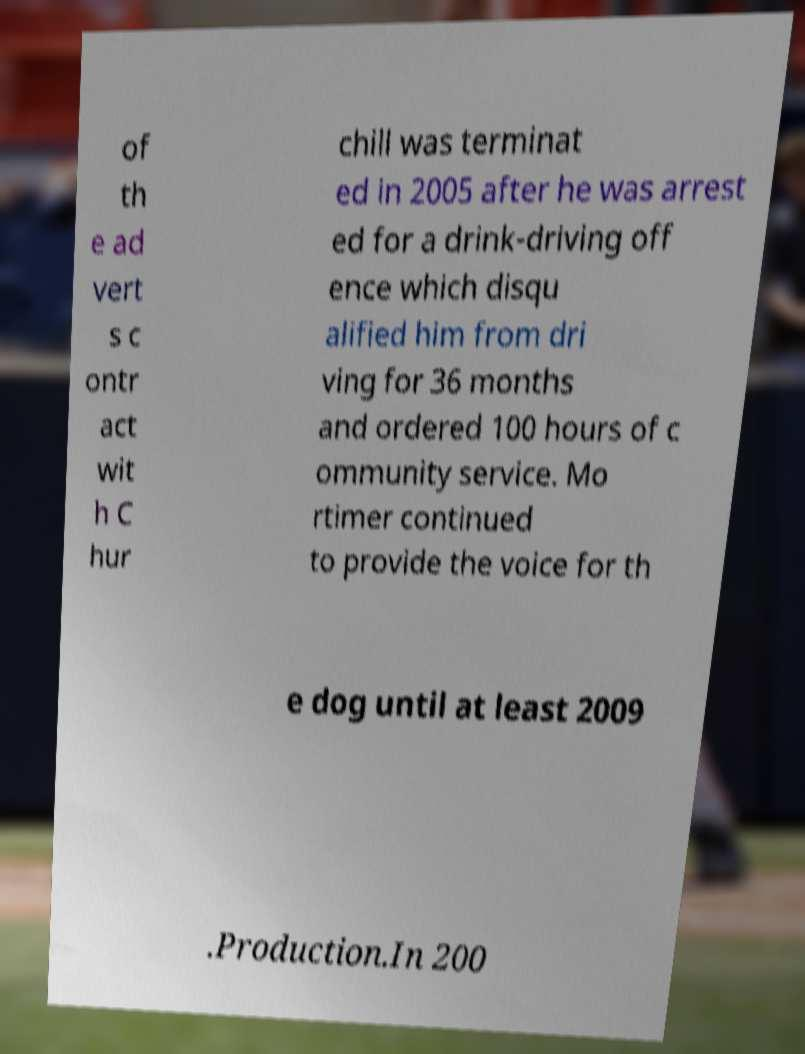Can you accurately transcribe the text from the provided image for me? of th e ad vert s c ontr act wit h C hur chill was terminat ed in 2005 after he was arrest ed for a drink-driving off ence which disqu alified him from dri ving for 36 months and ordered 100 hours of c ommunity service. Mo rtimer continued to provide the voice for th e dog until at least 2009 .Production.In 200 